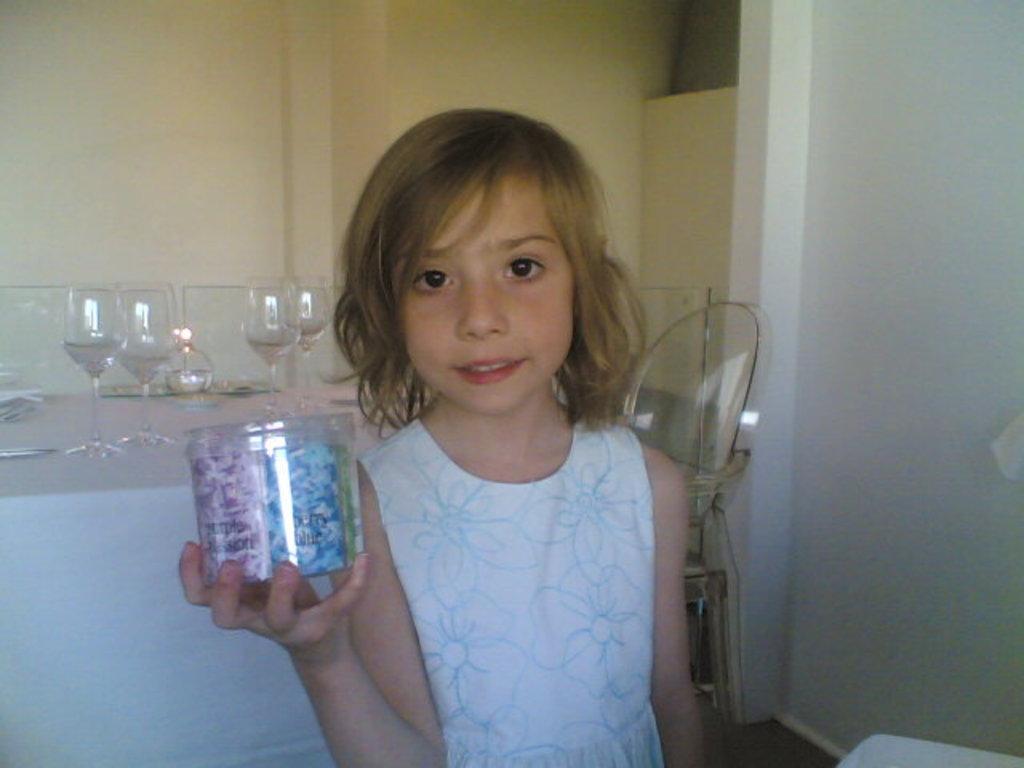In one or two sentences, can you explain what this image depicts? In this image in the front there is a girl standing and holding an object in her hand. In the background there are glasses and there is a wall which is yellow in colour. 